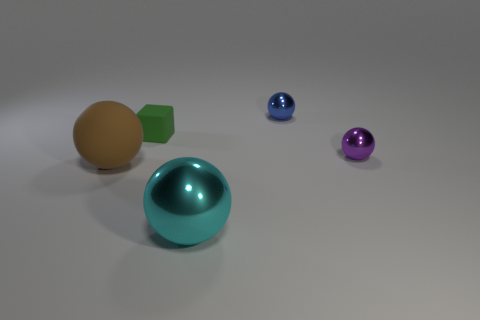There is a metallic sphere that is to the left of the blue ball; does it have the same size as the tiny green matte object?
Offer a very short reply. No. There is a ball in front of the large ball that is behind the metal thing in front of the purple metallic ball; what is its color?
Keep it short and to the point. Cyan. The rubber ball has what color?
Your response must be concise. Brown. Does the big matte object have the same color as the cube?
Your answer should be compact. No. Do the big sphere that is to the right of the big brown rubber sphere and the small purple sphere that is behind the brown object have the same material?
Your response must be concise. Yes. What material is the purple object that is the same shape as the brown matte object?
Your response must be concise. Metal. Is the green cube made of the same material as the brown sphere?
Provide a succinct answer. Yes. There is a large thing in front of the big object that is behind the cyan object; what is its color?
Offer a very short reply. Cyan. What is the size of the blue sphere that is the same material as the cyan thing?
Provide a succinct answer. Small. What number of small blue metallic things are the same shape as the cyan metallic object?
Your response must be concise. 1. 